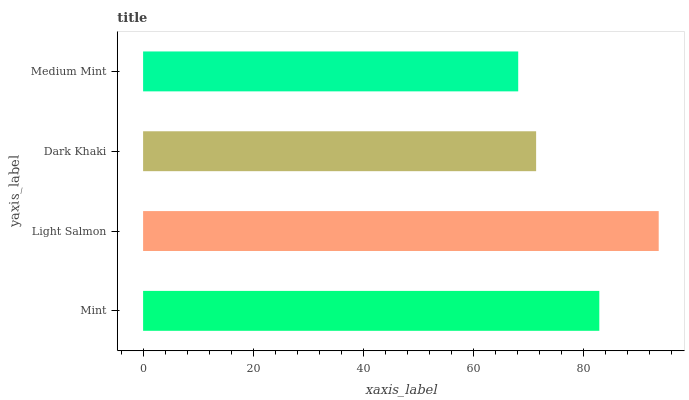Is Medium Mint the minimum?
Answer yes or no. Yes. Is Light Salmon the maximum?
Answer yes or no. Yes. Is Dark Khaki the minimum?
Answer yes or no. No. Is Dark Khaki the maximum?
Answer yes or no. No. Is Light Salmon greater than Dark Khaki?
Answer yes or no. Yes. Is Dark Khaki less than Light Salmon?
Answer yes or no. Yes. Is Dark Khaki greater than Light Salmon?
Answer yes or no. No. Is Light Salmon less than Dark Khaki?
Answer yes or no. No. Is Mint the high median?
Answer yes or no. Yes. Is Dark Khaki the low median?
Answer yes or no. Yes. Is Medium Mint the high median?
Answer yes or no. No. Is Medium Mint the low median?
Answer yes or no. No. 